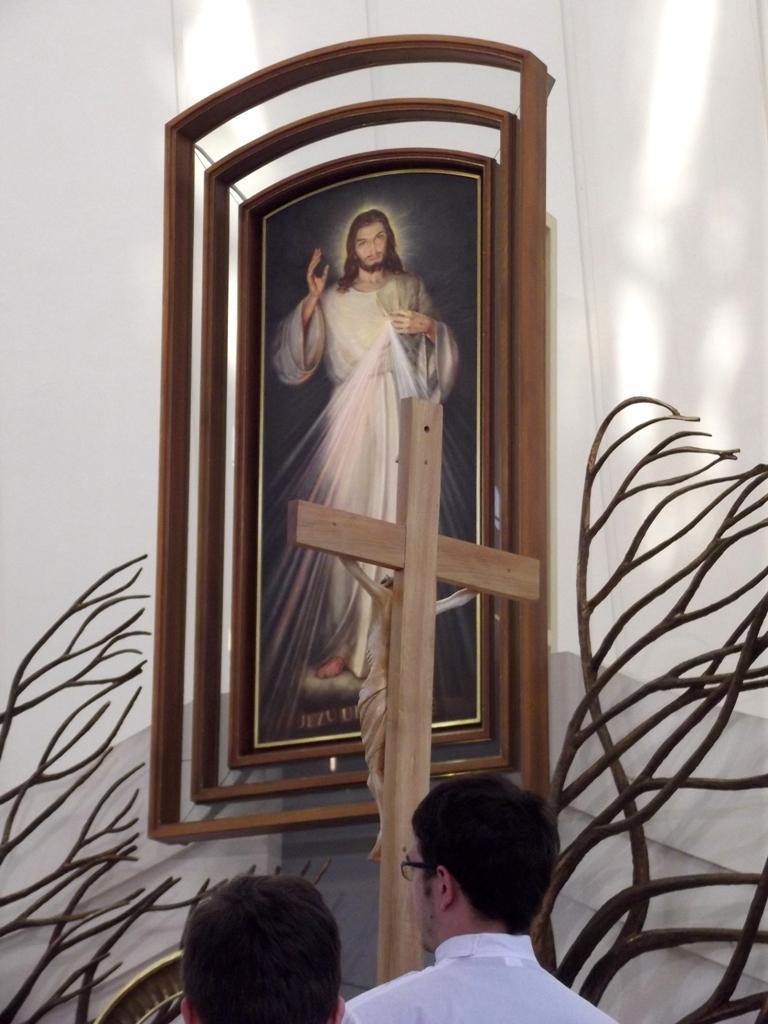How would you summarize this image in a sentence or two? In this image we can see two persons at the bottom. Also there is a cross. On the cross there is a statue. And we can see branches. And there is a photo frame on the wall. 